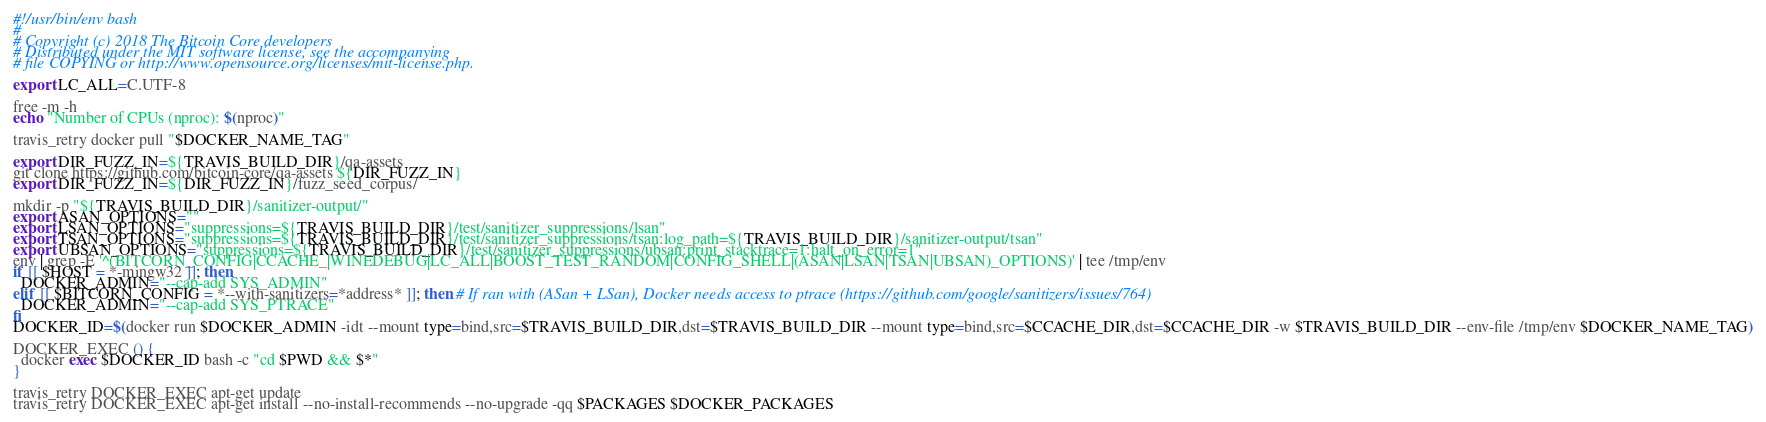<code> <loc_0><loc_0><loc_500><loc_500><_Bash_>#!/usr/bin/env bash
#
# Copyright (c) 2018 The Bitcoin Core developers
# Distributed under the MIT software license, see the accompanying
# file COPYING or http://www.opensource.org/licenses/mit-license.php.

export LC_ALL=C.UTF-8

free -m -h
echo "Number of CPUs (nproc): $(nproc)"

travis_retry docker pull "$DOCKER_NAME_TAG"

export DIR_FUZZ_IN=${TRAVIS_BUILD_DIR}/qa-assets
git clone https://github.com/bitcoin-core/qa-assets ${DIR_FUZZ_IN}
export DIR_FUZZ_IN=${DIR_FUZZ_IN}/fuzz_seed_corpus/

mkdir -p "${TRAVIS_BUILD_DIR}/sanitizer-output/"
export ASAN_OPTIONS=""
export LSAN_OPTIONS="suppressions=${TRAVIS_BUILD_DIR}/test/sanitizer_suppressions/lsan"
export TSAN_OPTIONS="suppressions=${TRAVIS_BUILD_DIR}/test/sanitizer_suppressions/tsan:log_path=${TRAVIS_BUILD_DIR}/sanitizer-output/tsan"
export UBSAN_OPTIONS="suppressions=${TRAVIS_BUILD_DIR}/test/sanitizer_suppressions/ubsan:print_stacktrace=1:halt_on_error=1"
env | grep -E '^(BITCORN_CONFIG|CCACHE_|WINEDEBUG|LC_ALL|BOOST_TEST_RANDOM|CONFIG_SHELL|(ASAN|LSAN|TSAN|UBSAN)_OPTIONS)' | tee /tmp/env
if [[ $HOST = *-mingw32 ]]; then
  DOCKER_ADMIN="--cap-add SYS_ADMIN"
elif [[ $BITCORN_CONFIG = *--with-sanitizers=*address* ]]; then # If ran with (ASan + LSan), Docker needs access to ptrace (https://github.com/google/sanitizers/issues/764)
  DOCKER_ADMIN="--cap-add SYS_PTRACE"
fi
DOCKER_ID=$(docker run $DOCKER_ADMIN -idt --mount type=bind,src=$TRAVIS_BUILD_DIR,dst=$TRAVIS_BUILD_DIR --mount type=bind,src=$CCACHE_DIR,dst=$CCACHE_DIR -w $TRAVIS_BUILD_DIR --env-file /tmp/env $DOCKER_NAME_TAG)

DOCKER_EXEC () {
  docker exec $DOCKER_ID bash -c "cd $PWD && $*"
}

travis_retry DOCKER_EXEC apt-get update
travis_retry DOCKER_EXEC apt-get install --no-install-recommends --no-upgrade -qq $PACKAGES $DOCKER_PACKAGES

</code> 